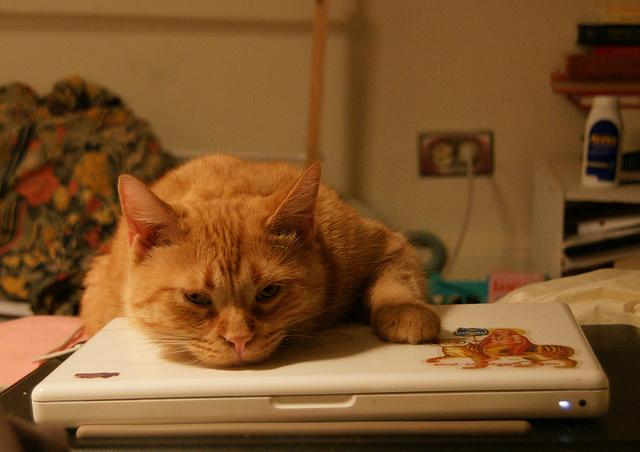What is the cat doing?
Keep it brief. Resting. What brand is the bottle in the background?
Be succinct. Aleve. What is pictured on the sticker?
Short answer required. Cat. Does this photo suggest isolation?
Keep it brief. No. What is the cat on top of?
Give a very brief answer. Laptop. 